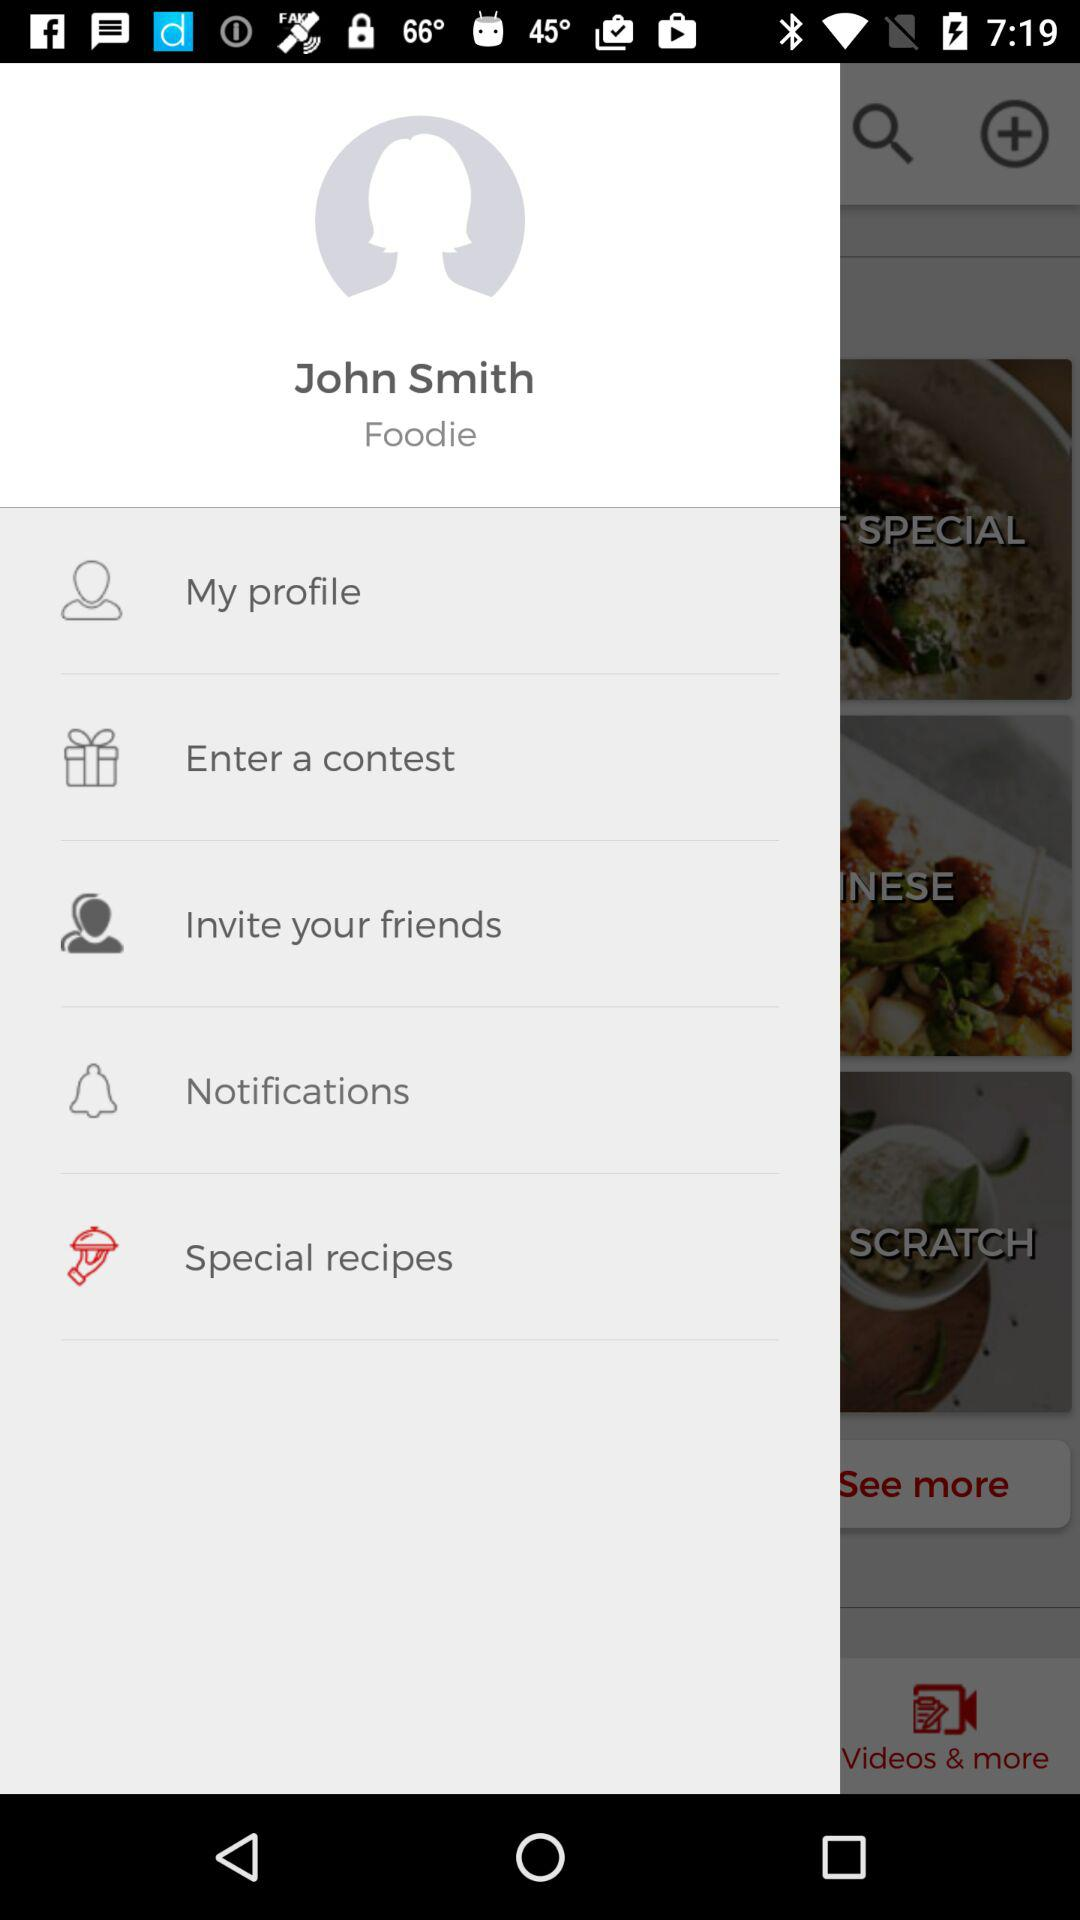What is the account holder's name? The account holder's name is John Smith. 